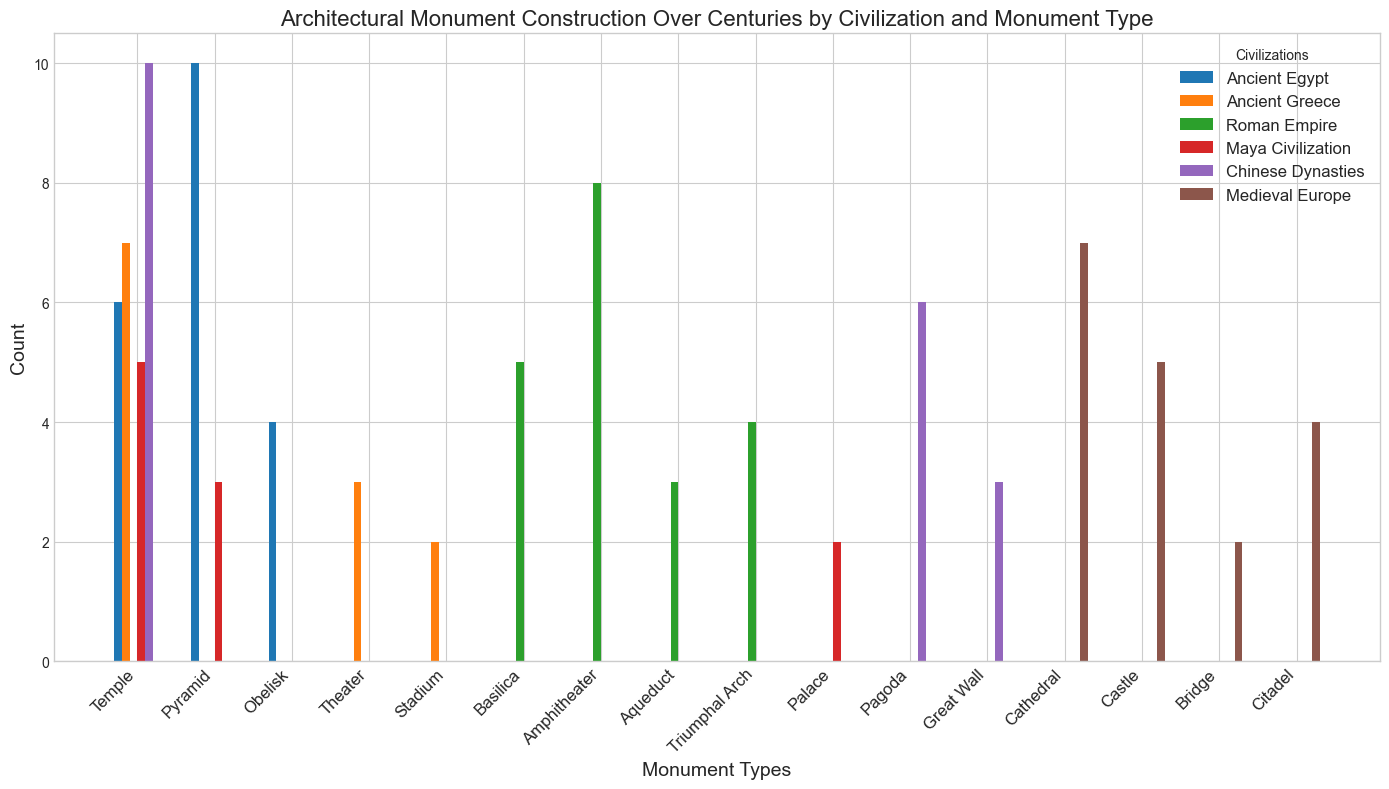Which civilization constructed the most temples? By comparing the bar heights for temples across different civilizations, we find that Chinese Dynasties constructed 10 temples, which is the highest number.
Answer: Chinese Dynasties What monument type was built the most by the Roman Empire? By reviewing the various monument types constructed by the Roman Empire and their corresponding counts, we see that the Amphitheater has the highest count with 8 constructions.
Answer: Amphitheater How many more pyramids did Ancient Egypt build compared to the Maya Civilization? Ancient Egypt built 10 pyramids while the Maya Civilization built 3. The difference is 10 - 3 = 7.
Answer: 7 Which civilization built more different types of monuments? By counting the number of different monument types constructed by each civilization, we find that the Roman Empire and Medieval Europe both built four distinct types of monuments.
Answer: Roman Empire and Medieval Europe Of the civilizations shown, which one constructed the fewest obelisks? There is only one civilization, Ancient Egypt, which constructed obelisks, with a total count of 4. Therefore, the other civilizations didn't construct any obelisks and thus have the fewest.
Answer: All except Ancient Egypt Considering the total count of constructions from Medieval Europe, what’s the average number of constructions per monument type? Medieval Europe constructed 7 Cathedrals, 5 Castles, 2 Bridges, and 4 Citadels. The total is 7 + 5 + 2 + 4 = 18. Dividing this by 4 monument types, the average is 18/4 = 4.5.
Answer: 4.5 Which monument type was constructed the least across all civilizations? By looking at all the monument types and finding the one with the smallest total count, we see that the Bridge has the least constructions with a count of 2 by Medieval Europe only.
Answer: Bridge Compare the constructions of temples between Ancient Greece and Chinese Dynasties. Which civilization constructed more, and by how much? Ancient Greece constructed 7 temples while Chinese Dynasties constructed 10 temples. The difference is 10 - 7 = 3. Hence, Chinese Dynasties constructed 3 more temples.
Answer: Chinese Dynasties by 3 How many more constructions did the Roman Empire have in the 1st BCE century compared to the 1st CE century? The Roman Empire constructed 8 Amphitheaters in the 1st BCE and 3 Aqueducts in the 1st CE. The difference is 8 - 3 = 5.
Answer: 5 How does the number of stadiums compare to basilicas across all civilizations? By adding the counts for stadiums (2 by Ancient Greece) and basilicas (5 by the Roman Empire), we see that there are 5 basilicas and 2 stadiums, 5 > 2.
Answer: Basilicas are more 